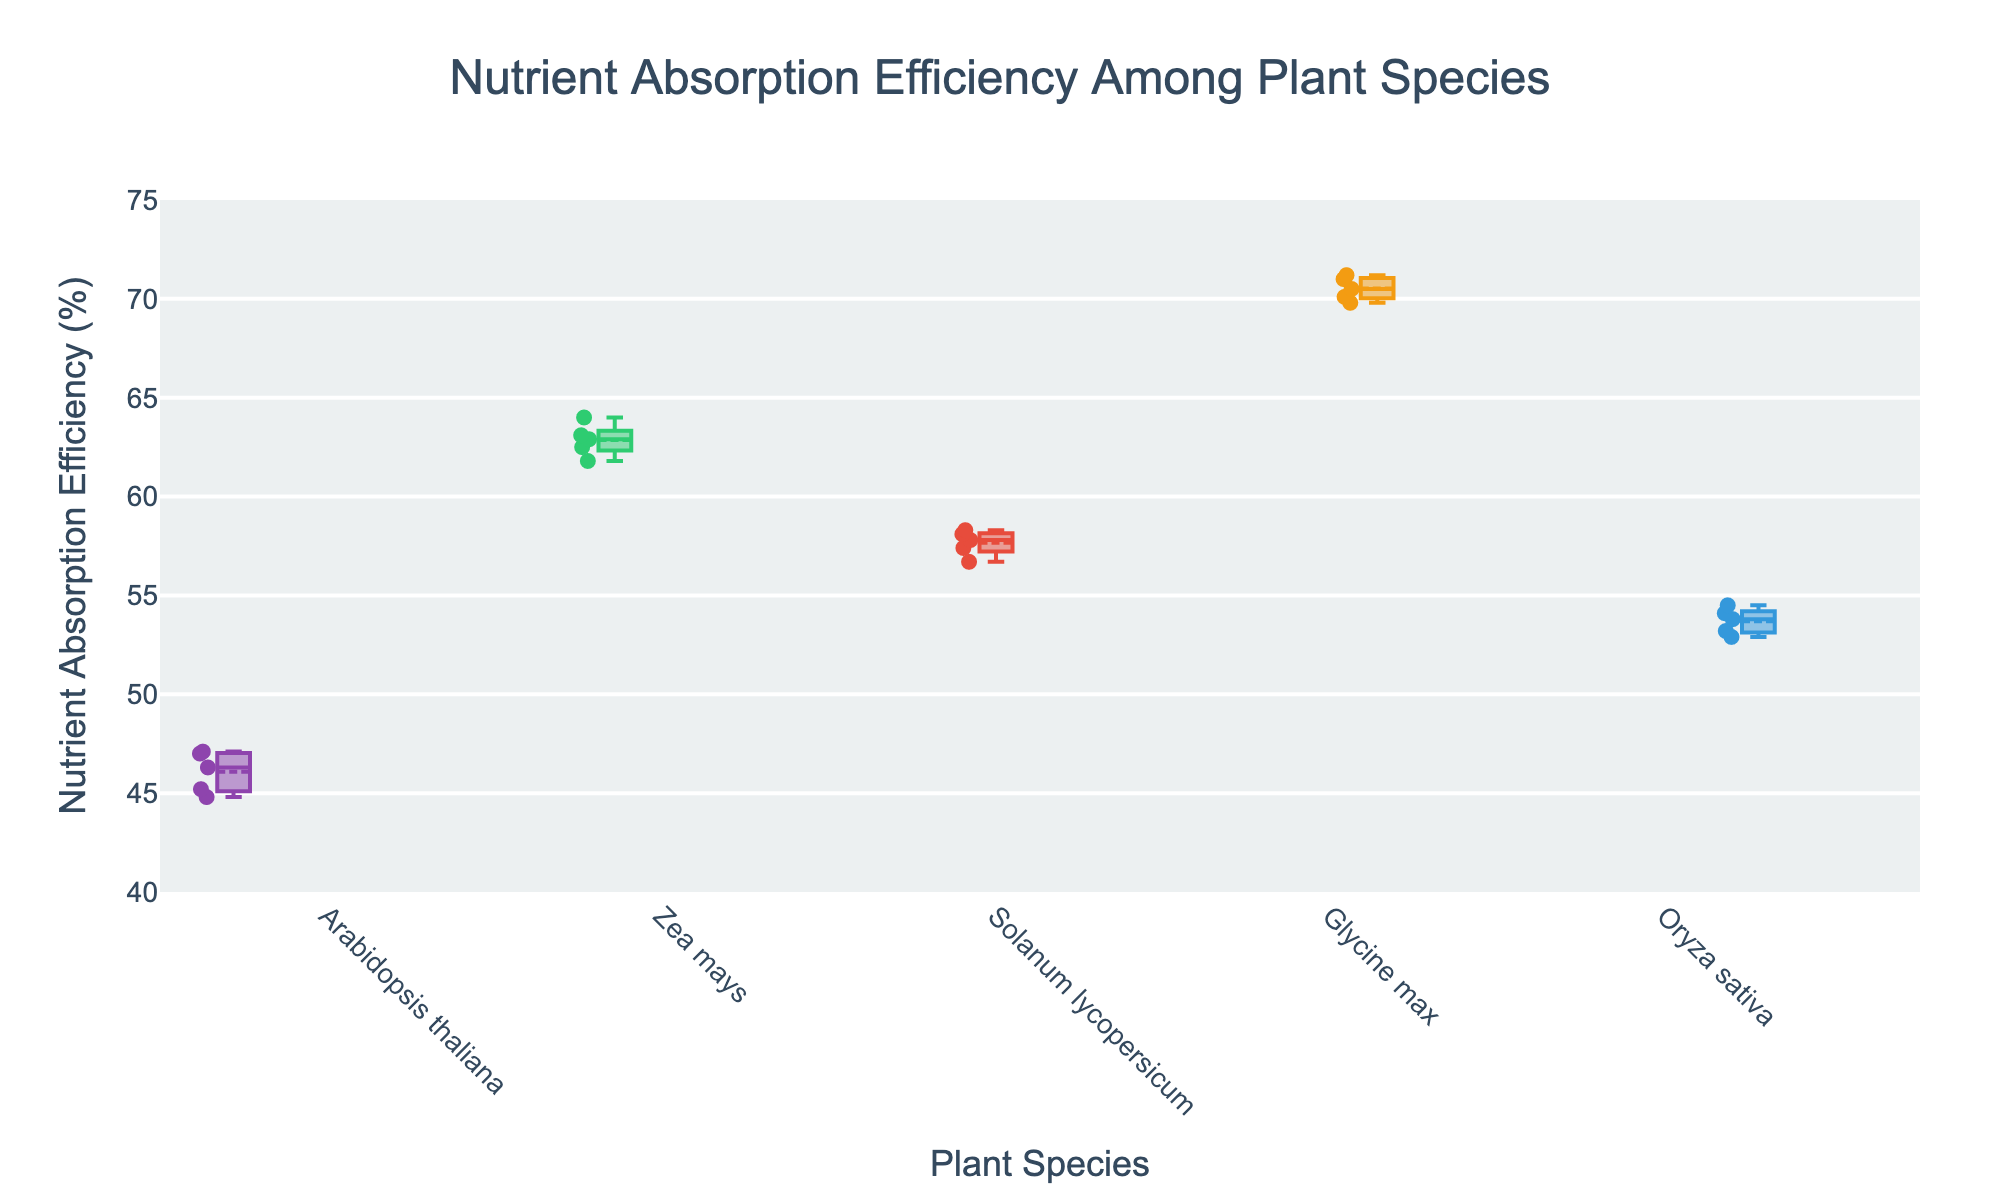What is the title of the figure? The title is displayed at the top of the figure. It reads: "Nutrient Absorption Efficiency Among Plant Species".
Answer: Nutrient Absorption Efficiency Among Plant Species Which plant species has the highest median nutrient absorption efficiency? The median is represented by the line inside each box. The highest line is in the "Glycine max" box.
Answer: Glycine max What is the range of nutrient absorption efficiency for Zea mays? The range is shown by the length of the box and whiskers. For Zea mays, it spans from approximately 61.8% to 64.0%.
Answer: 61.8% to 64.0% Which plant species shows the lowest minimum nutrient absorption efficiency? The minimum value is indicated by the lower whisker. The lowest whisker is for Arabidopsis thaliana.
Answer: Arabidopsis thaliana What is the difference in median nutrient absorption efficiency between Arabidopsis thaliana and Oryza sativa? The median value for Arabidopsis thaliana is around 46%, and for Oryza sativa, it is around 54%. The difference is calculated as 54 - 46.
Answer: 8% How many plant species have their median nutrient absorption efficiency above 55%? By checking the lines inside the boxes, we find that Zea mays, Solanum lycopersicum, and Glycine max have medians above 55%.
Answer: 3 Which plant species has the widest interquartile range (IQR) in nutrient absorption efficiency? The IQR is the length of the box. Glycine max has the widest box, indicating the widest IQR.
Answer: Glycine max Are there any outliers in the nutrient absorption efficiency data for any plant species? Outliers are usually represented as individual points outside the whiskers. In this figure, there are no points outside the whiskers for any species.
Answer: No What is the median nutrient absorption efficiency for Solanum lycopersicum? The median is the line in the middle of the box for Solanum lycopersicum, which is about 57.8%.
Answer: 57.8% Which plant species appears to have the most consistent nutrient absorption efficiency? Consistency can be inferred from the shortest whiskers and box. "Zea mays" appears to have the shortest range and thus seems the most consistent.
Answer: Zea mays 